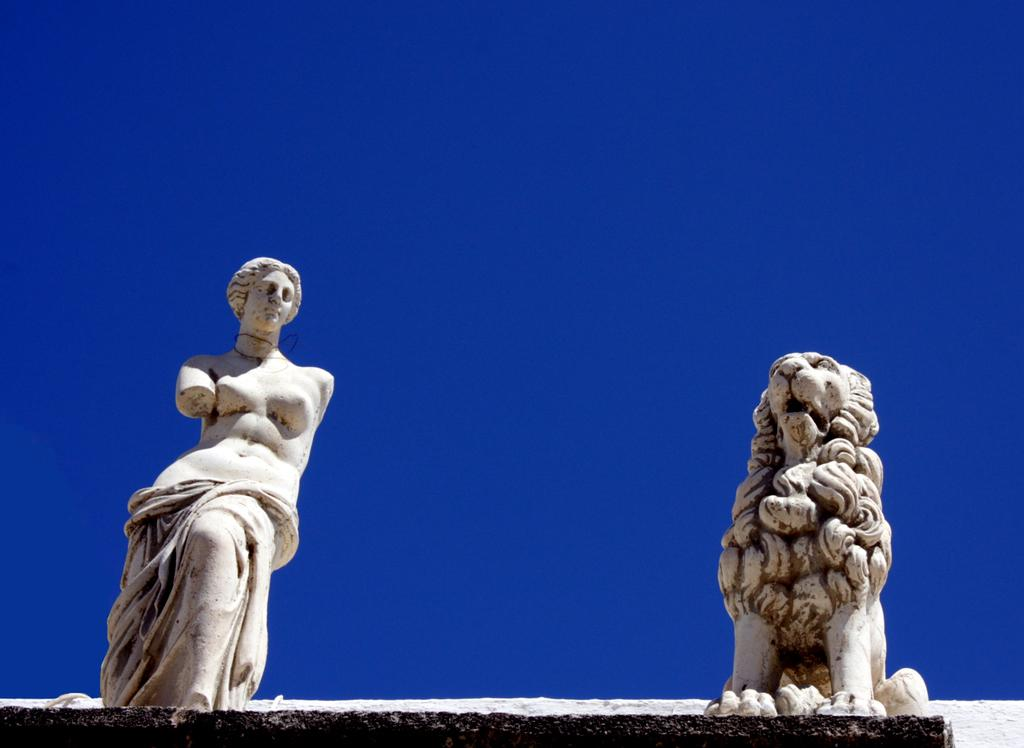What objects are present in the image? There are statues in the image. What can be seen in the background of the image? There is a sky visible in the background of the image. What type of tray is being used by the statues in the image? There is no tray present in the image, as it features statues and a sky visible in the background. What time of day is it in the image? The time of day cannot be determined from the image, as it only shows statues and a sky visible in the background. 